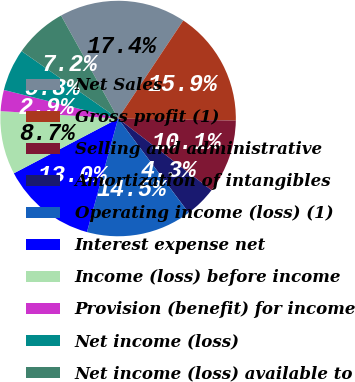Convert chart. <chart><loc_0><loc_0><loc_500><loc_500><pie_chart><fcel>Net Sales<fcel>Gross profit (1)<fcel>Selling and administrative<fcel>Amortization of intangibles<fcel>Operating income (loss) (1)<fcel>Interest expense net<fcel>Income (loss) before income<fcel>Provision (benefit) for income<fcel>Net income (loss)<fcel>Net income (loss) available to<nl><fcel>17.39%<fcel>15.94%<fcel>10.14%<fcel>4.35%<fcel>14.49%<fcel>13.04%<fcel>8.7%<fcel>2.9%<fcel>5.8%<fcel>7.25%<nl></chart> 